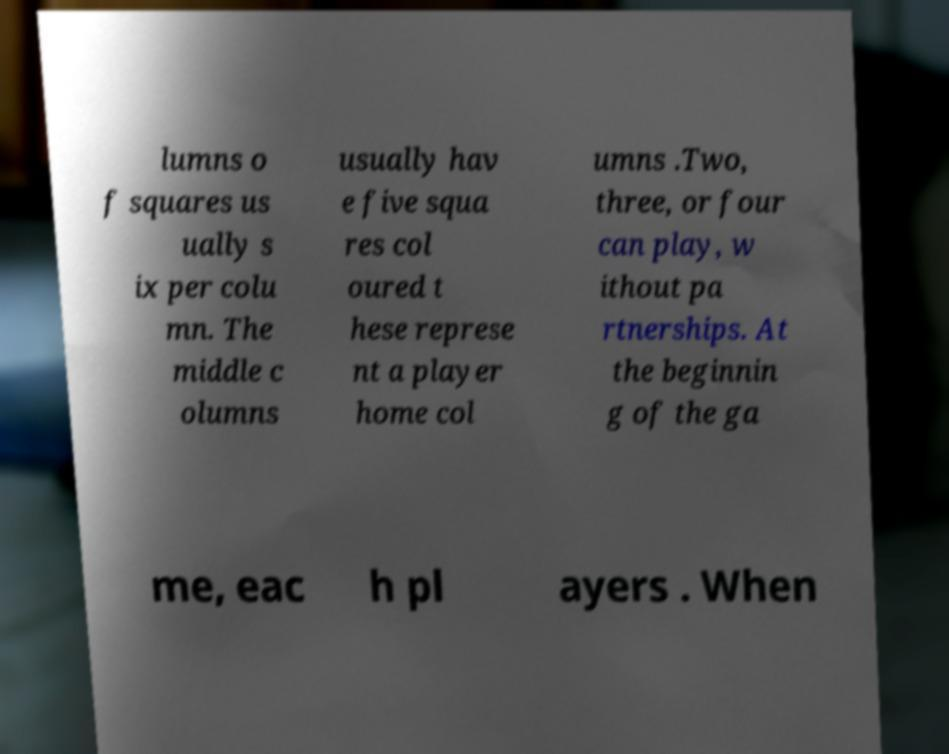Please read and relay the text visible in this image. What does it say? lumns o f squares us ually s ix per colu mn. The middle c olumns usually hav e five squa res col oured t hese represe nt a player home col umns .Two, three, or four can play, w ithout pa rtnerships. At the beginnin g of the ga me, eac h pl ayers . When 